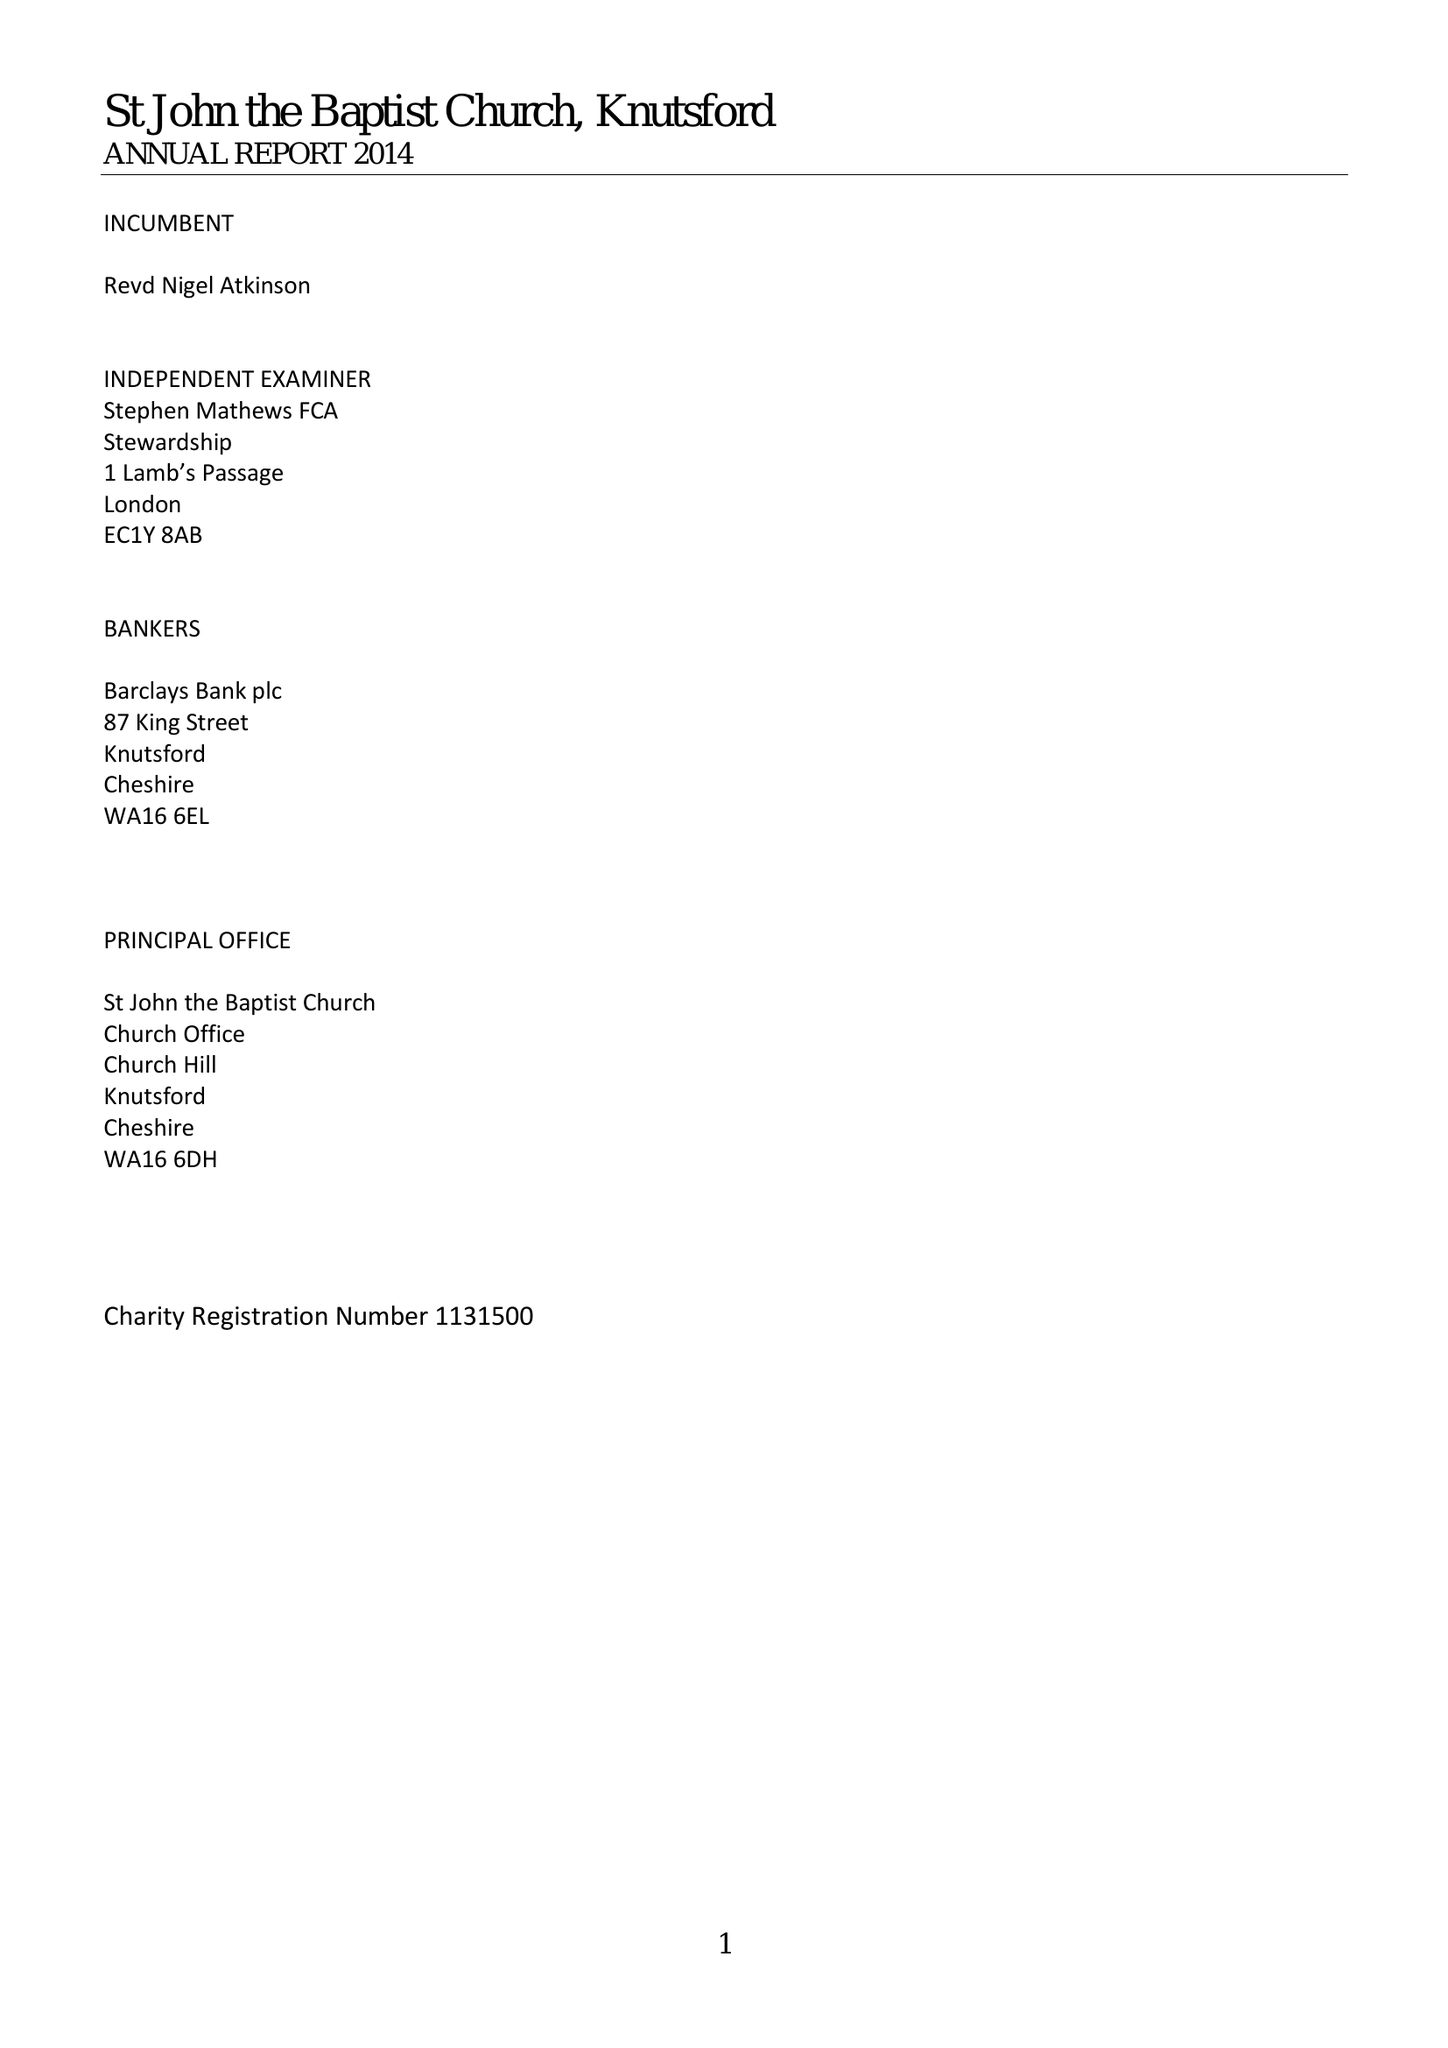What is the value for the address__street_line?
Answer the question using a single word or phrase. CHURCH HILL 